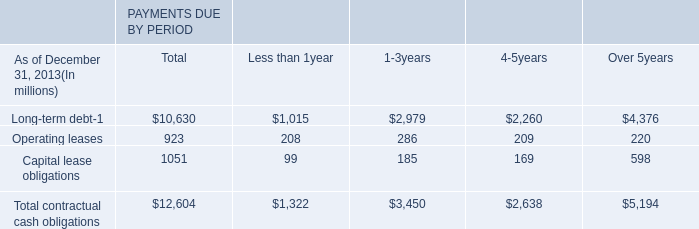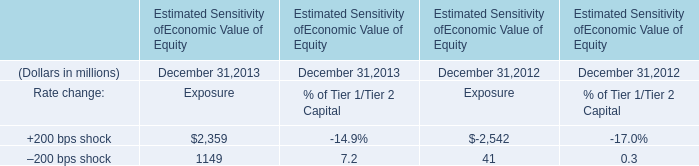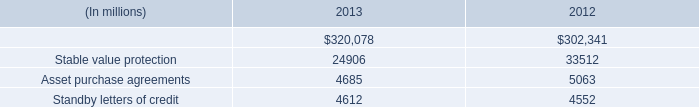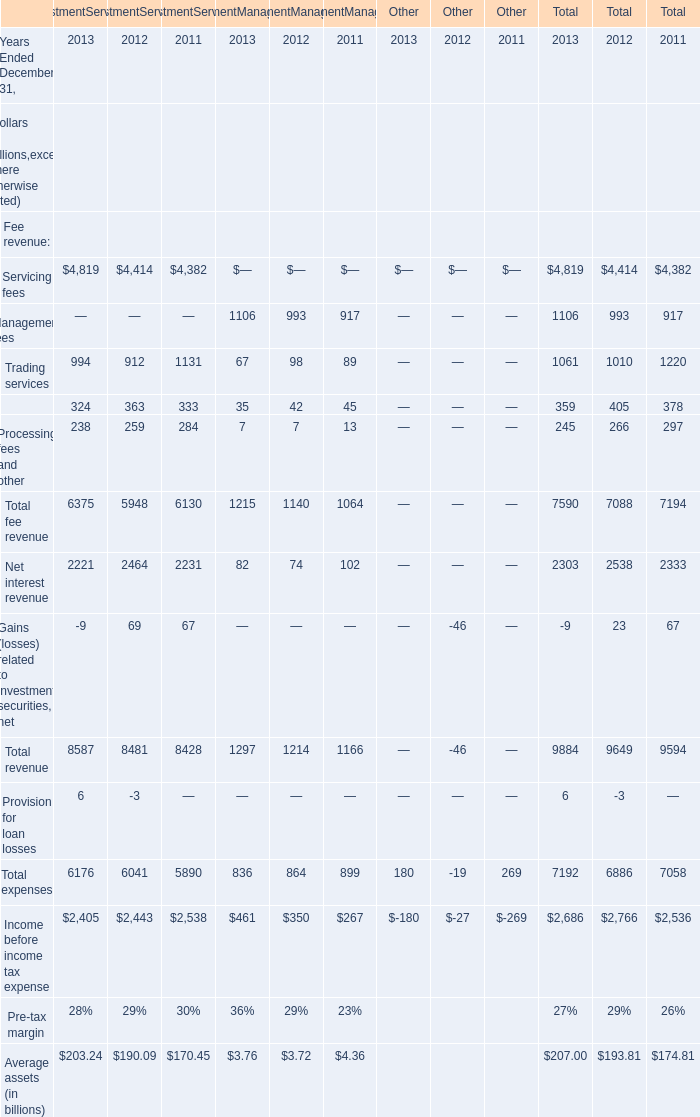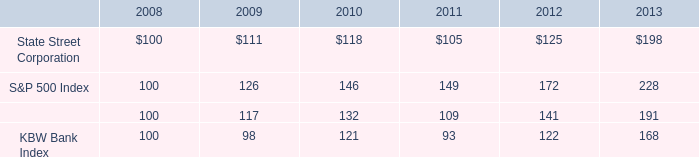In the year with largest amount of Servicing fees what's the sum of Trading services and Securities finance in InvestmentServicing (in million) 
Computations: (994 + 324)
Answer: 1318.0. 